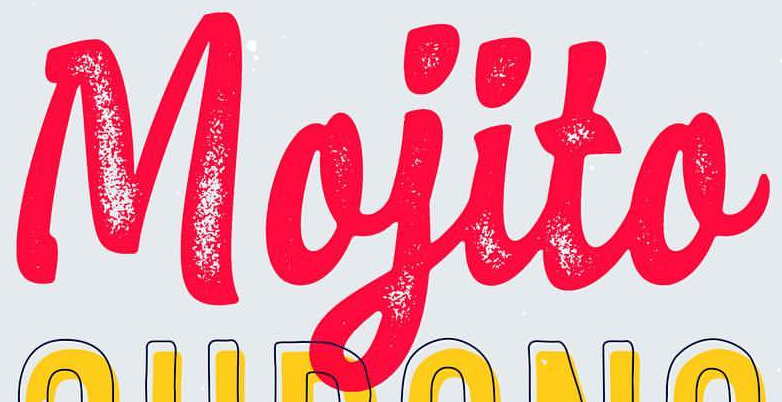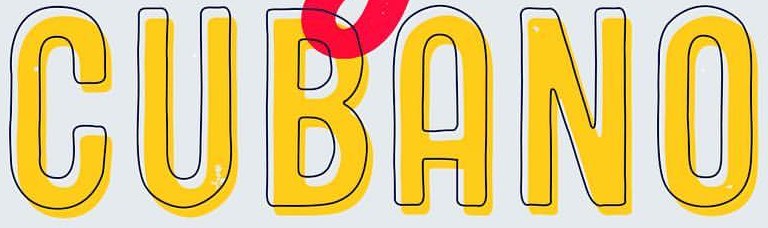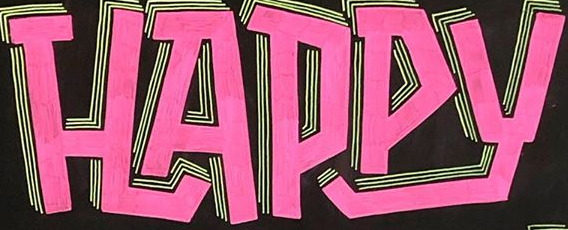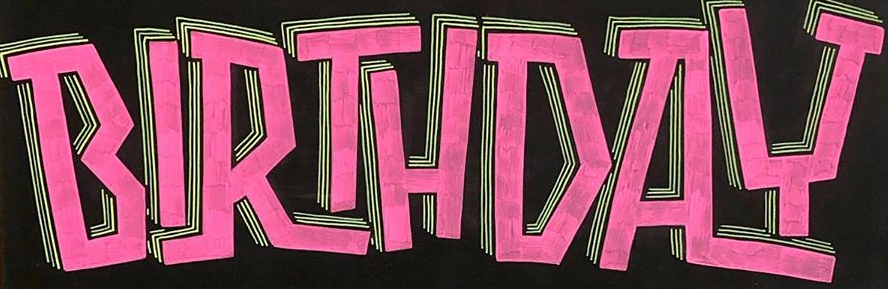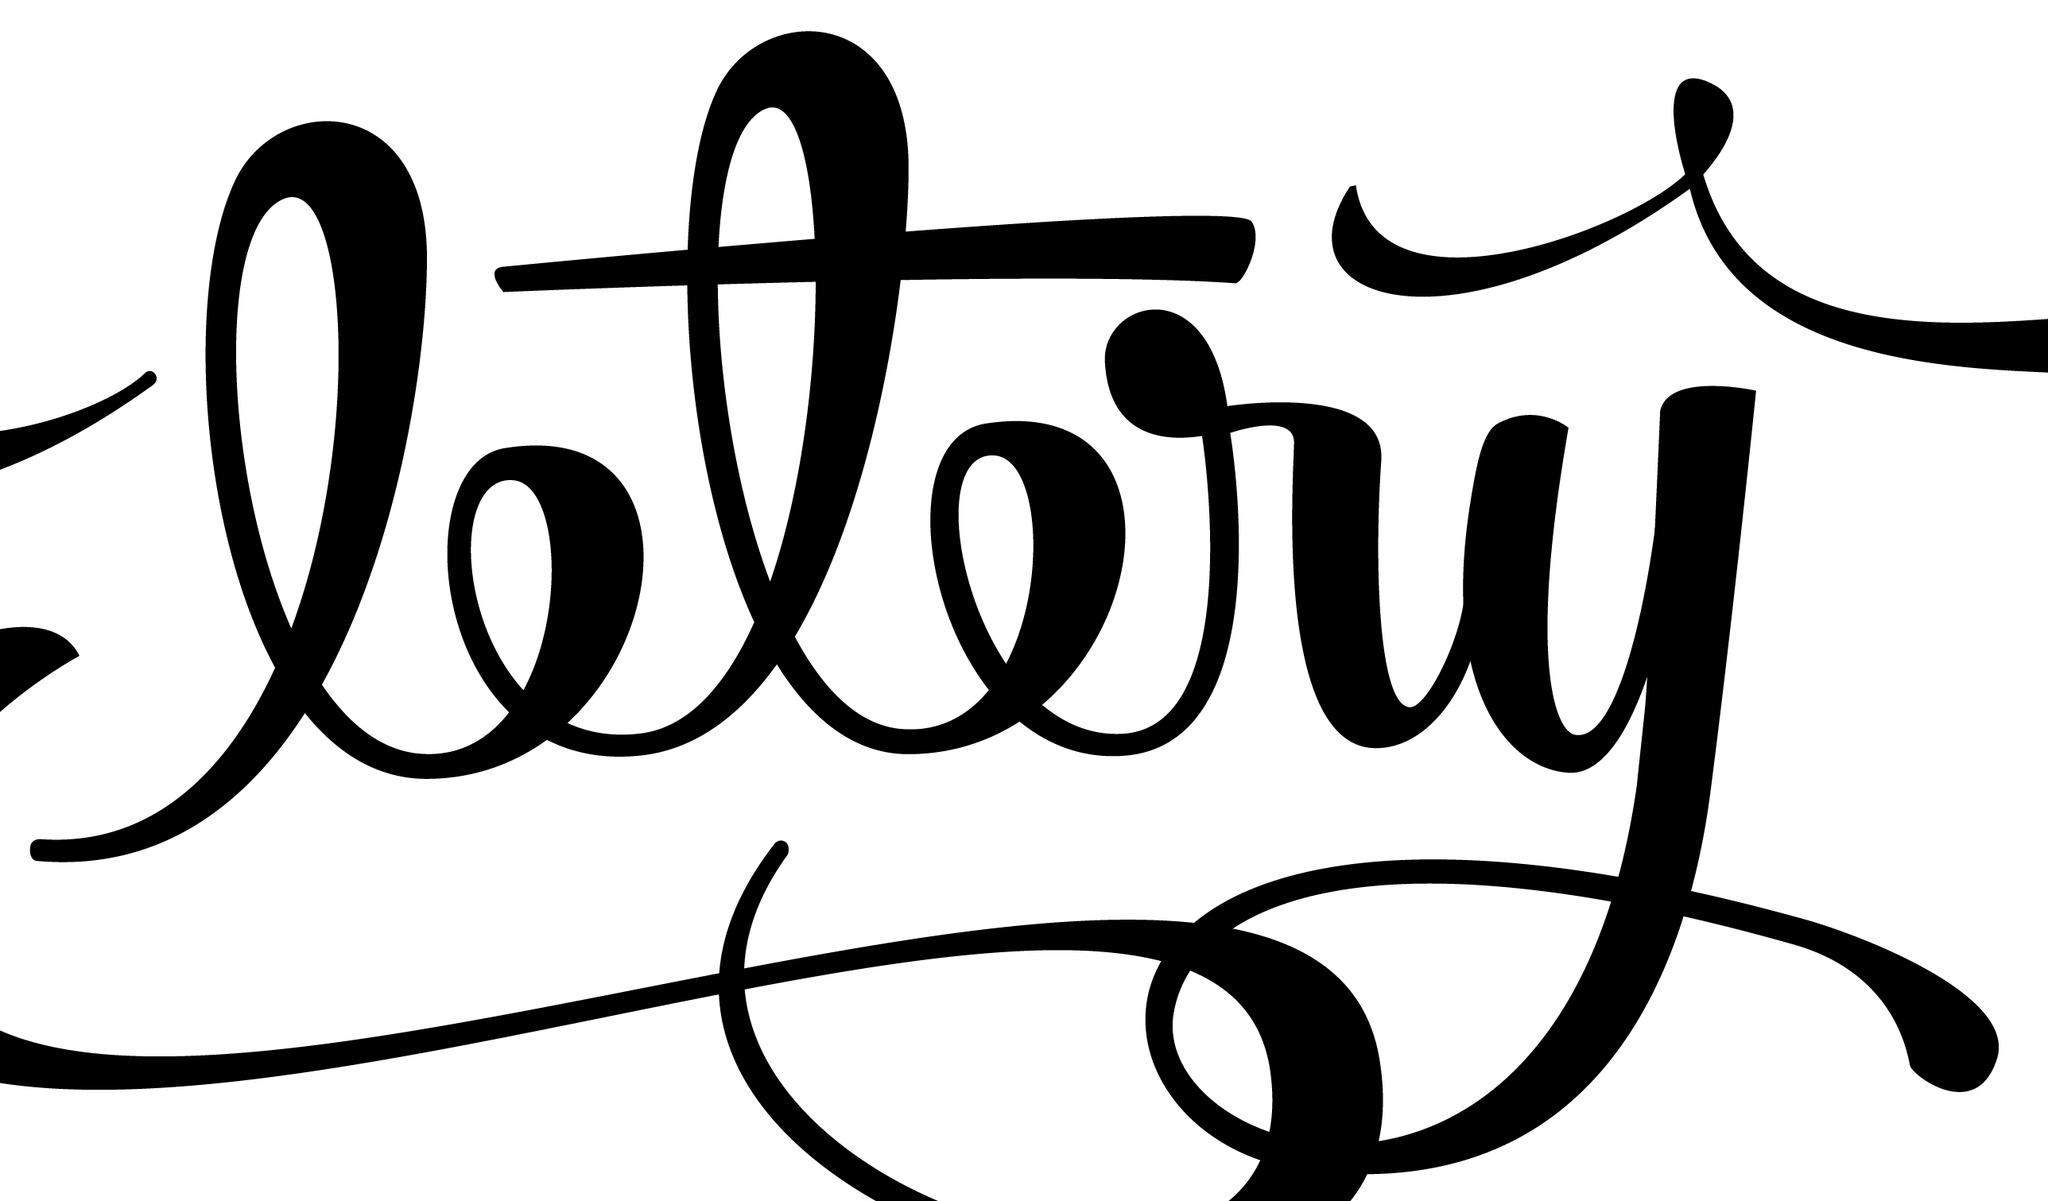What text is displayed in these images sequentially, separated by a semicolon? Mojito; CUBANO; HAPPY; BIRTHDAY; ltry 